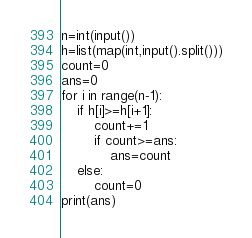Convert code to text. <code><loc_0><loc_0><loc_500><loc_500><_Python_>n=int(input())
h=list(map(int,input().split()))
count=0
ans=0
for i in range(n-1):
    if h[i]>=h[i+1]:
        count+=1
        if count>=ans:
            ans=count
    else:
        count=0
print(ans)</code> 